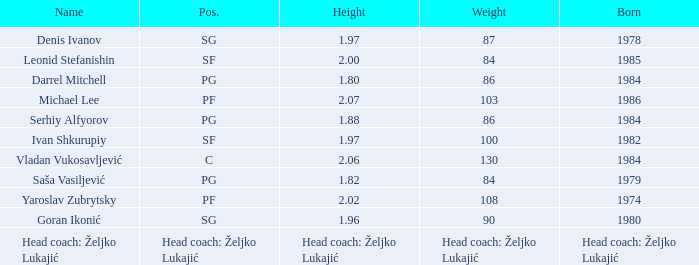What is the weight of the person born in 1980? 90.0. 